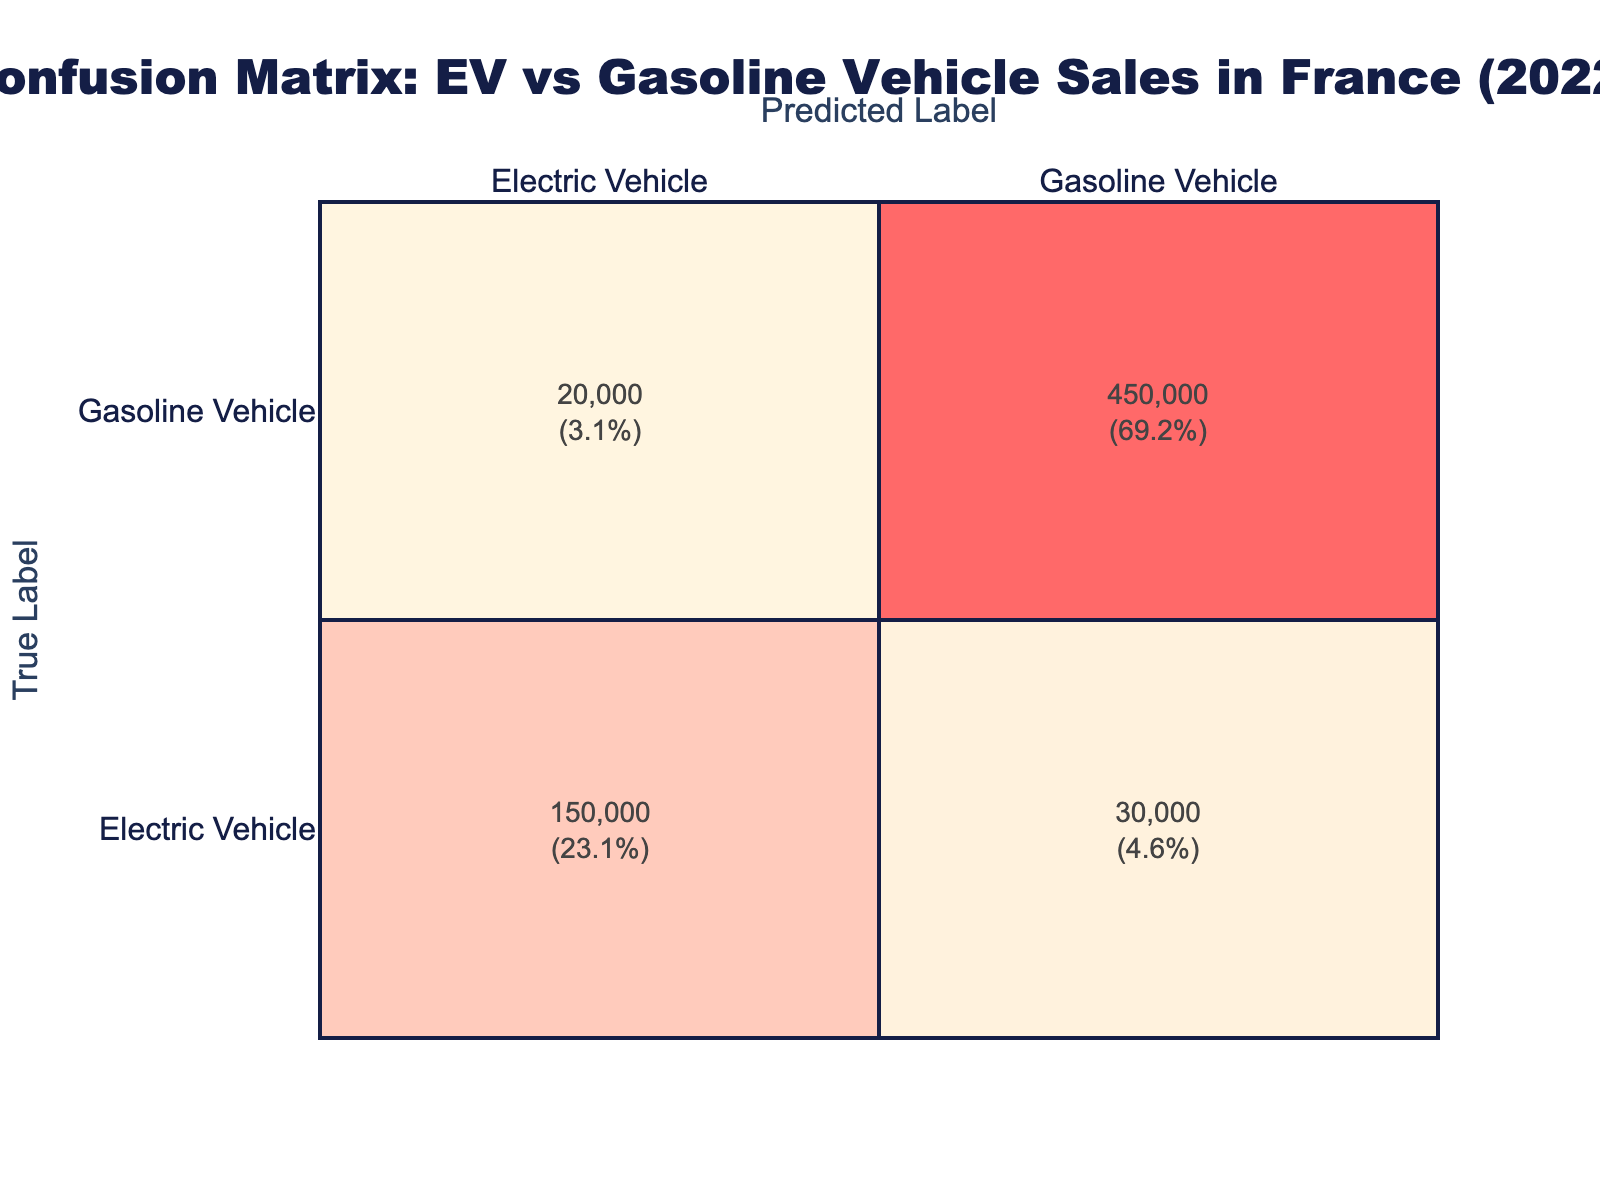What is the total count of correctly predicted electric vehicle sales? To find the total count of correctly predicted electric vehicle sales, we look at the cell where both True Label and Predicted Label are "Electric Vehicle." According to the table, this count is 150,000.
Answer: 150000 What percentage of gasoline vehicle sales were correctly predicted? The count for correctly predicted gasoline vehicle sales is found in the cell where both True Label and Predicted Label are "Gasoline Vehicle," which is 450,000. To find the percentage, the total number of predictions is 150,000 + 30,000 + 20,000 + 450,000 = 650,000. Then, (450,000 / 650,000) * 100 = 69.2%.
Answer: 69.2% Are there more misclassifications for electric vehicles or gasoline vehicles? To determine this, we need to look at the misclassifications: For electric vehicles, the misclassifications are 30,000 (predicted as Gasoline) and 20,000 (predicted as Electric), totaling 50,000. For gasoline vehicles, the misclassification is just 20,000 (predicted as Electric). Comparing, 50,000 > 20,000, so there are more misclassifications for electric vehicles.
Answer: Yes What is the total count of sales predicted as gasoline vehicles? To find the total count of sales predicted as gasoline vehicles, we add the counts from both the "Gasoline Vehicle" rows. The counts are 450,000 (correctly predicted) and 20,000 (misclassified as Electric Vehicle), resulting in a total of 450,000 + 20,000 = 470,000.
Answer: 470000 What is the ratio of correctly predicted electric vehicle sales to the total predicted electric vehicle sales? The correctly predicted electric vehicle sales are 150,000. The total predicted electric vehicle sales include the correctly predicted (150,000) and the misclassifications (20,000 + 30,000 = 50,000), giving us 150,000 + 50,000 = 200,000. Thus, the ratio is 150,000 / 200,000 = 0.75, or 75%.
Answer: 75% 